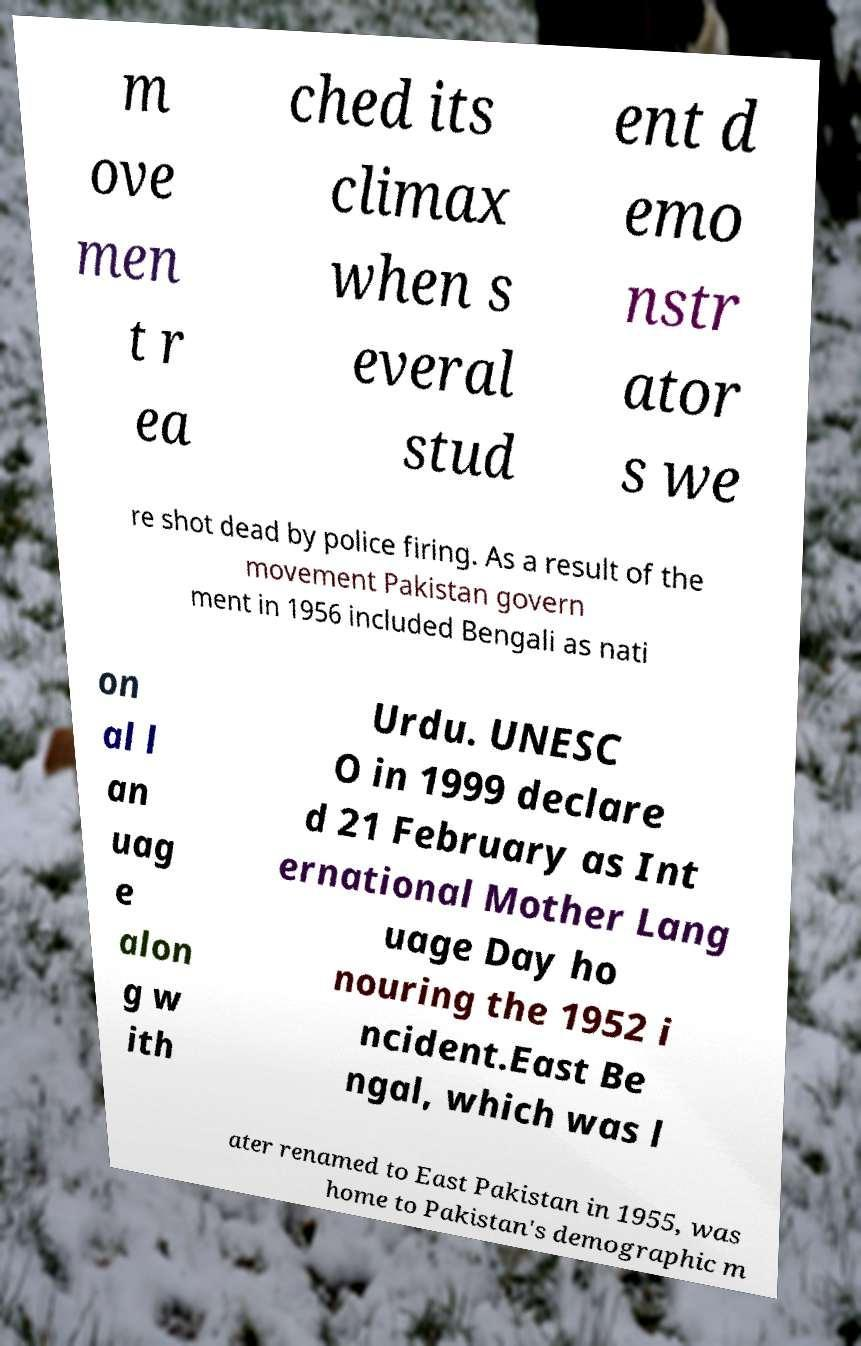What messages or text are displayed in this image? I need them in a readable, typed format. m ove men t r ea ched its climax when s everal stud ent d emo nstr ator s we re shot dead by police firing. As a result of the movement Pakistan govern ment in 1956 included Bengali as nati on al l an uag e alon g w ith Urdu. UNESC O in 1999 declare d 21 February as Int ernational Mother Lang uage Day ho nouring the 1952 i ncident.East Be ngal, which was l ater renamed to East Pakistan in 1955, was home to Pakistan's demographic m 